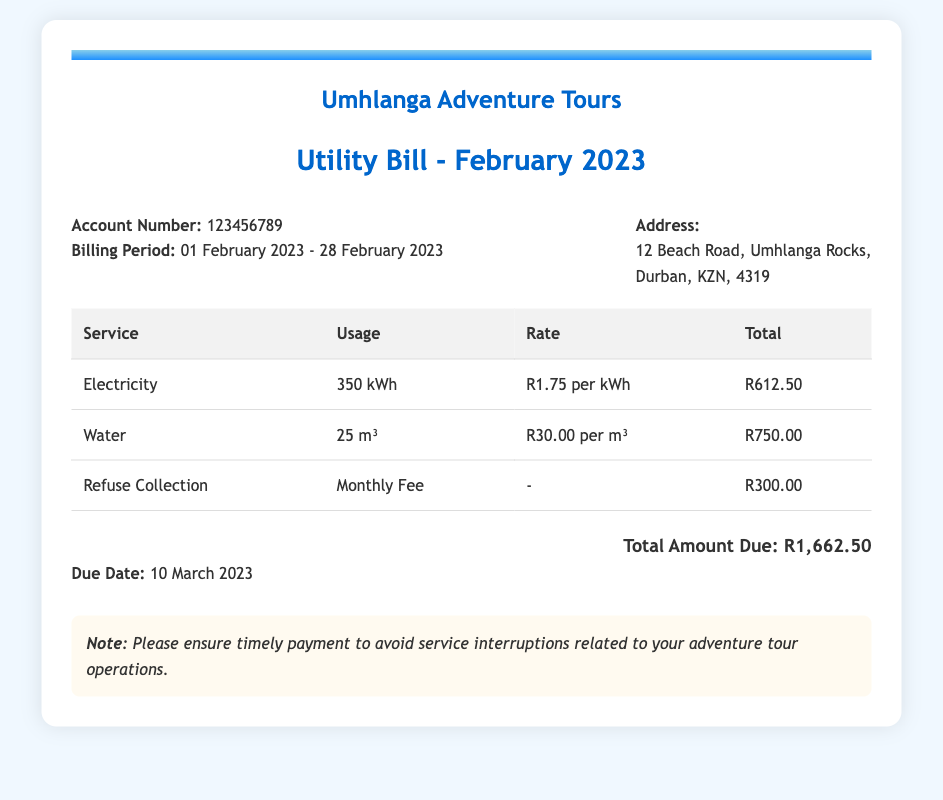what is the account number? The account number is a unique identifier for the billing account and is stated explicitly in the document.
Answer: 123456789 what is the billing period? The billing period outlines the start and end dates of the service for which the bill is generated, as clearly mentioned in the document.
Answer: 01 February 2023 - 28 February 2023 how much is the total amount due? The total amount due is the final summation of all service charges listed in the document and is highlighted at the end.
Answer: R1,662.50 what is the due date for the payment? The due date is provided to ensure timely payment and is specifically noted in the document.
Answer: 10 March 2023 how many kWh of electricity was used? The document specifies the amount of electricity consumed during the billing period, which is listed in the table.
Answer: 350 kWh what is the rate for water service? The rate for water service is mentioned in the document, which indicates how much is charged per unit of water consumed.
Answer: R30.00 per m³ what is the total charge for refuse collection? The total charge for refuse collection is a fixed amount stated in the charges table of the document.
Answer: R300.00 which service incurred the highest charge? The highest charge can be determined by comparing the totals in the table, which shows the cost of each service.
Answer: Water what is the monthly fee for refuse collection? The monthly fee is specified in the charges section of the document distinctly for refuse collection.
Answer: R300.00 